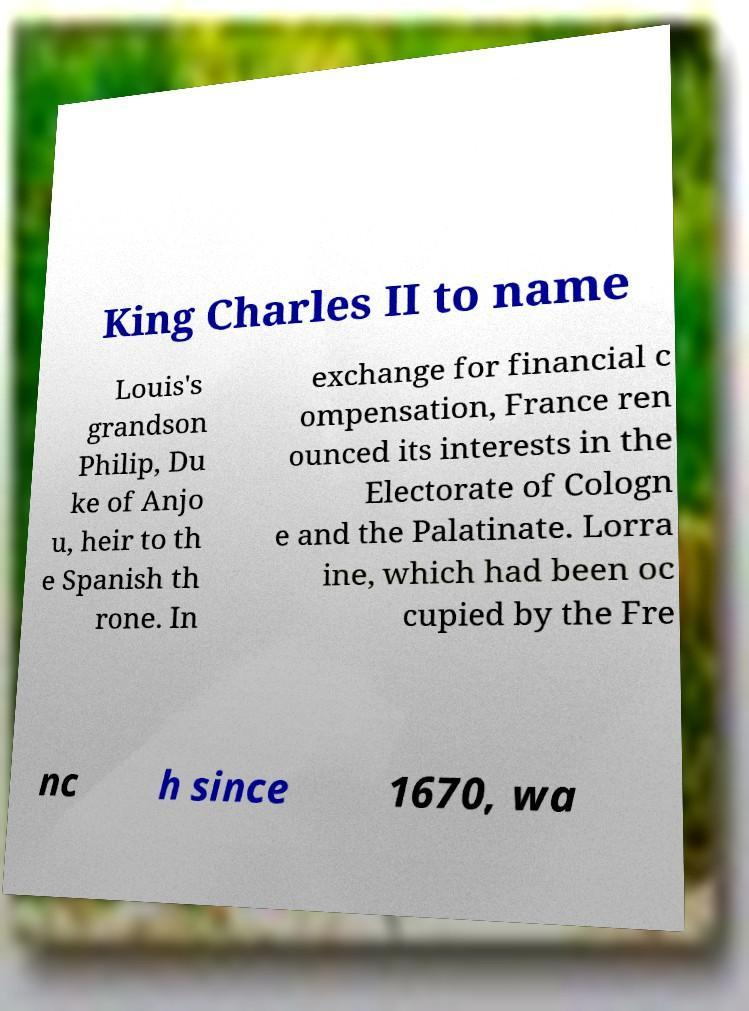What messages or text are displayed in this image? I need them in a readable, typed format. King Charles II to name Louis's grandson Philip, Du ke of Anjo u, heir to th e Spanish th rone. In exchange for financial c ompensation, France ren ounced its interests in the Electorate of Cologn e and the Palatinate. Lorra ine, which had been oc cupied by the Fre nc h since 1670, wa 